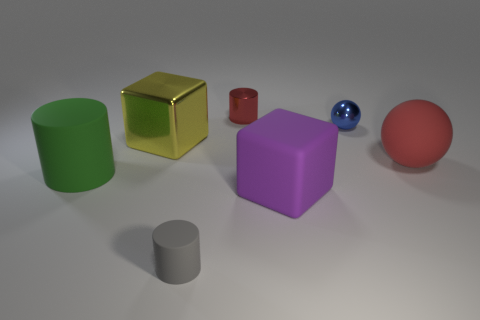How many objects are either blue spheres or big objects to the right of the gray cylinder?
Give a very brief answer. 3. The tiny sphere has what color?
Give a very brief answer. Blue. The big thing that is on the right side of the small blue sphere is what color?
Make the answer very short. Red. How many tiny red metallic cylinders are to the right of the large block in front of the matte sphere?
Your answer should be compact. 0. There is a green rubber cylinder; does it have the same size as the cylinder behind the big red sphere?
Give a very brief answer. No. Is there a yellow metallic ball of the same size as the green object?
Keep it short and to the point. No. What number of things are rubber things or tiny metallic objects?
Give a very brief answer. 6. Do the yellow metallic block in front of the red cylinder and the rubber cylinder to the right of the yellow object have the same size?
Your answer should be compact. No. Is there a tiny brown shiny object that has the same shape as the small red shiny thing?
Offer a very short reply. No. Are there fewer matte objects that are to the left of the big purple matte object than large yellow metal objects?
Provide a succinct answer. No. 